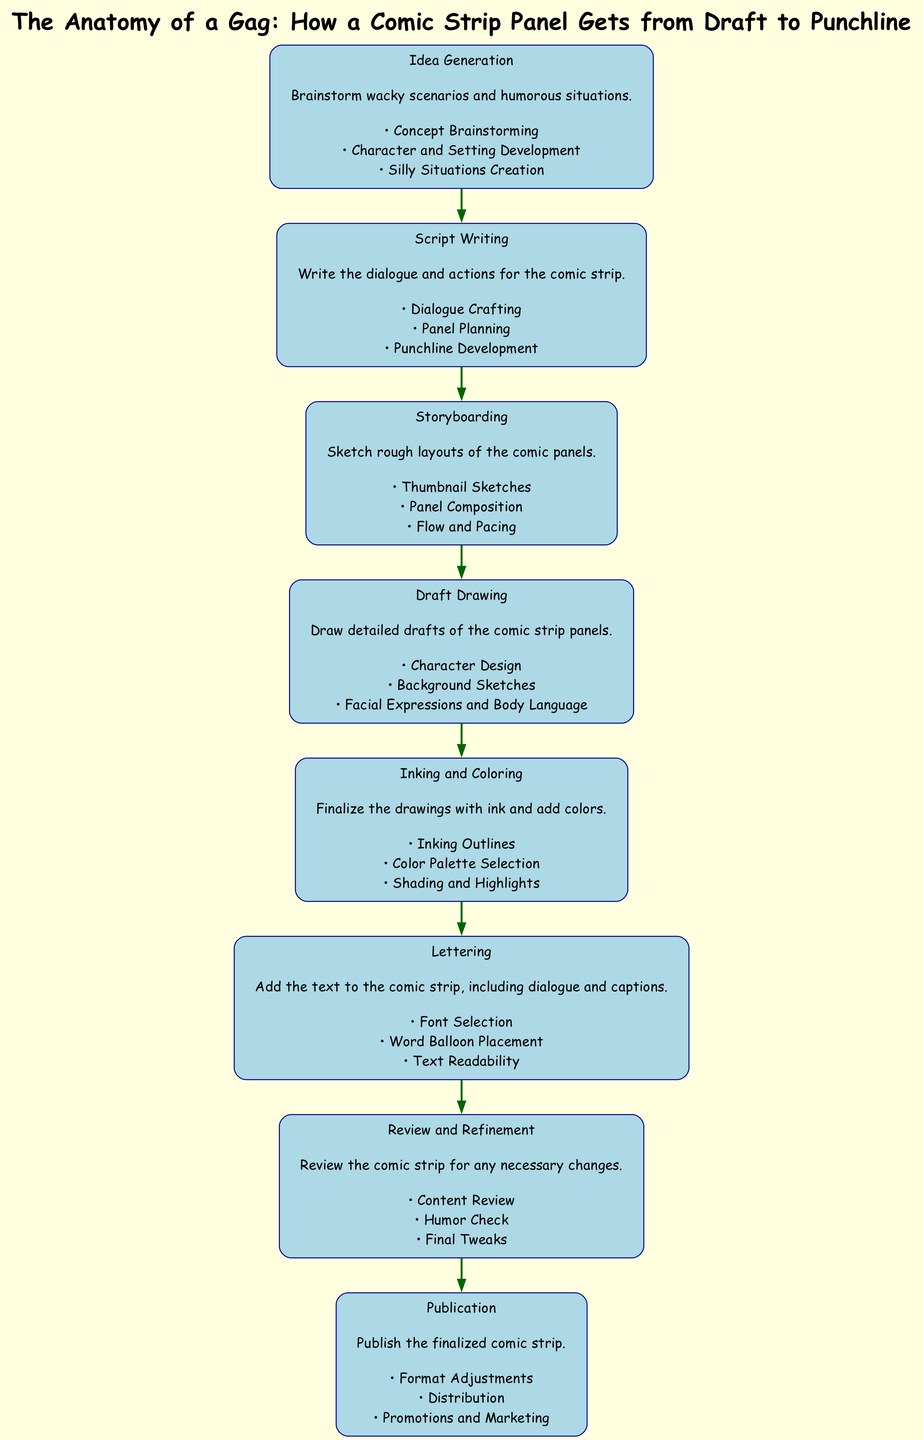What is the first element in the diagram? The first element is labeled as "Idea Generation," which encompasses brainstorming wacky scenarios and humorous situations. Locating the top node of the diagram gives us this information.
Answer: Idea Generation How many key activities are listed under "Script Writing"? Under "Script Writing," there are three key activities enumerated: Dialogue Crafting, Panel Planning, and Punchline Development. Counting these activities yields the answer.
Answer: 3 Which two elements are connected directly in the diagram? The elements "Draft Drawing" and "Inking and Coloring" are connected directly, as there is an edge linking these two components sequentially in the diagram.
Answer: Draft Drawing and Inking and Coloring What is the last element before publication? The last element before "Publication" is "Review and Refinement," which is crucial for making final adjustments before the comic strip is published. This is found by identifying the node that precedes "Publication."
Answer: Review and Refinement What are the key activities in "Storyboarding"? The key activities in "Storyboarding" include Thumbnail Sketches, Panel Composition, and Flow and Pacing. By examining the node for "Storyboarding," we can extract these activities directly.
Answer: Thumbnail Sketches, Panel Composition, Flow and Pacing How many total elements are represented in the diagram? The diagram contains a total of eight elements, each corresponding to a step in the process from idea generation to publication. Counting the nodes from the start to the end confirms this total.
Answer: 8 Which element focuses on sketching layouts? The element that focuses on sketching layouts is "Storyboarding," which is explicitly described in its description as the stage for rough layouts of comic panels.
Answer: Storyboarding What element comes after "Inking and Coloring"? The element that follows "Inking and Coloring" is "Lettering," which involves adding text to the comic strip, following the inking and coloring phase in the process.
Answer: Lettering 